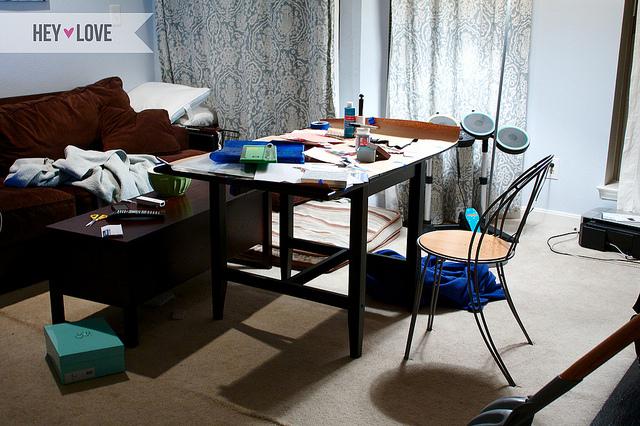Does the chair have lumbar support?
Short answer required. No. What is the item next to the window?
Answer briefly. Drums. What does the banner say?
Be succinct. Hey love. What is the color of the stool?
Answer briefly. Brown. Is this an office?
Answer briefly. No. Is that a drum set near the windows?
Answer briefly. Yes. 